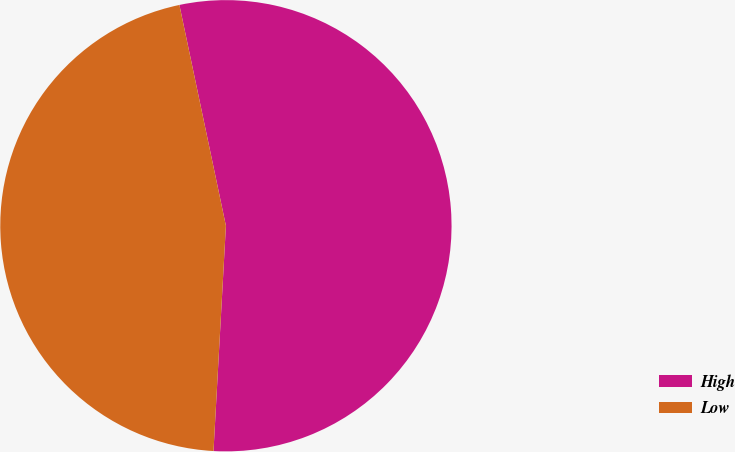Convert chart. <chart><loc_0><loc_0><loc_500><loc_500><pie_chart><fcel>High<fcel>Low<nl><fcel>54.18%<fcel>45.82%<nl></chart> 